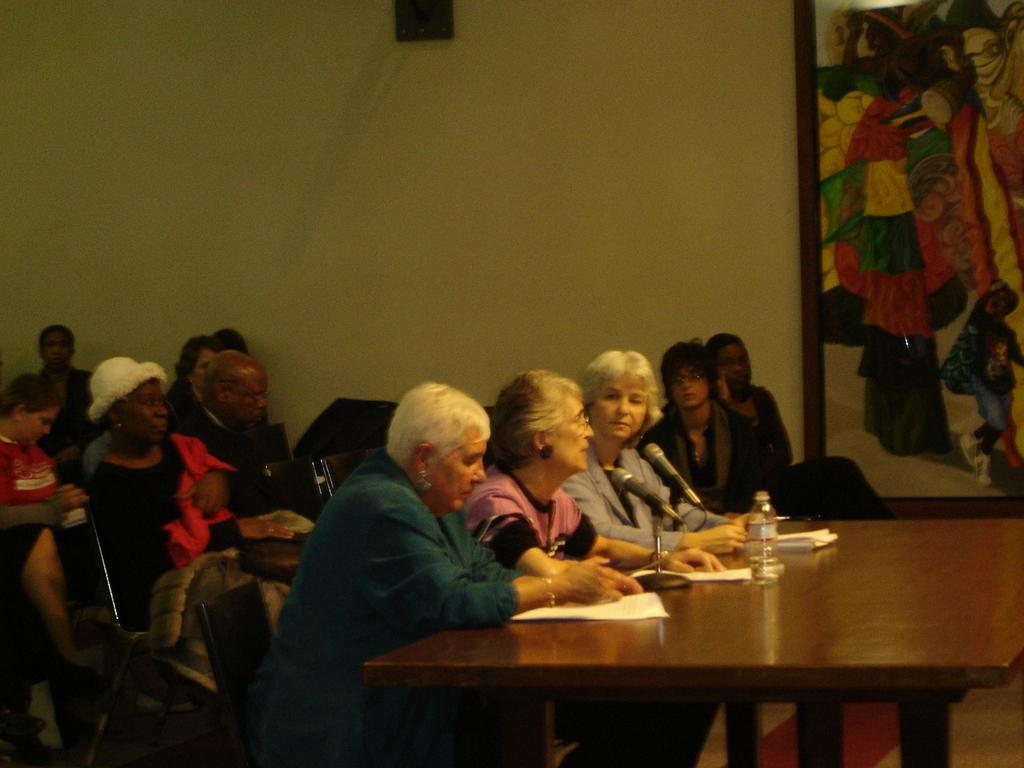What are the people in the image doing? The people in the image are seated on chairs. What can be seen on the table in the image? There is a water bottle and papers on the table in the image. What is hanging on the wall in the image? There is a photo frame on the wall in the image. Are there any bubbles floating around in the image? No, there are no bubbles present in the image. 